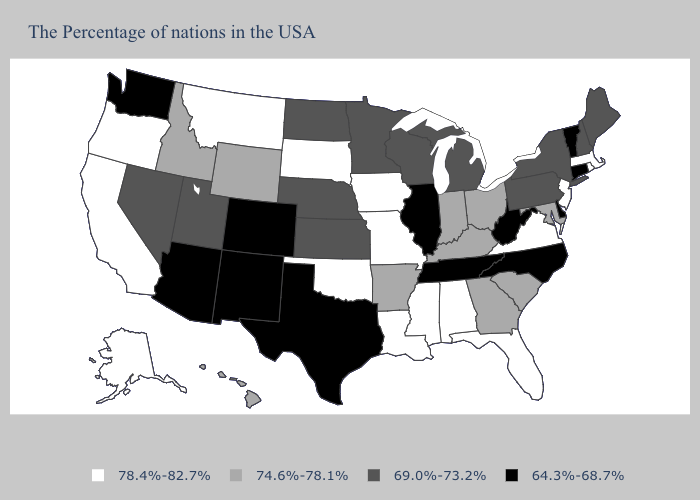What is the value of Colorado?
Keep it brief. 64.3%-68.7%. Name the states that have a value in the range 78.4%-82.7%?
Short answer required. Massachusetts, Rhode Island, New Jersey, Virginia, Florida, Alabama, Mississippi, Louisiana, Missouri, Iowa, Oklahoma, South Dakota, Montana, California, Oregon, Alaska. What is the highest value in the MidWest ?
Short answer required. 78.4%-82.7%. Does Florida have a higher value than Maryland?
Give a very brief answer. Yes. Name the states that have a value in the range 64.3%-68.7%?
Give a very brief answer. Vermont, Connecticut, Delaware, North Carolina, West Virginia, Tennessee, Illinois, Texas, Colorado, New Mexico, Arizona, Washington. Name the states that have a value in the range 64.3%-68.7%?
Quick response, please. Vermont, Connecticut, Delaware, North Carolina, West Virginia, Tennessee, Illinois, Texas, Colorado, New Mexico, Arizona, Washington. What is the value of Louisiana?
Write a very short answer. 78.4%-82.7%. What is the lowest value in the USA?
Quick response, please. 64.3%-68.7%. Name the states that have a value in the range 64.3%-68.7%?
Quick response, please. Vermont, Connecticut, Delaware, North Carolina, West Virginia, Tennessee, Illinois, Texas, Colorado, New Mexico, Arizona, Washington. What is the value of Minnesota?
Give a very brief answer. 69.0%-73.2%. Does the map have missing data?
Quick response, please. No. What is the highest value in states that border Maryland?
Concise answer only. 78.4%-82.7%. Does North Dakota have a lower value than New Hampshire?
Be succinct. No. What is the value of Alaska?
Answer briefly. 78.4%-82.7%. Does Tennessee have the highest value in the USA?
Answer briefly. No. 